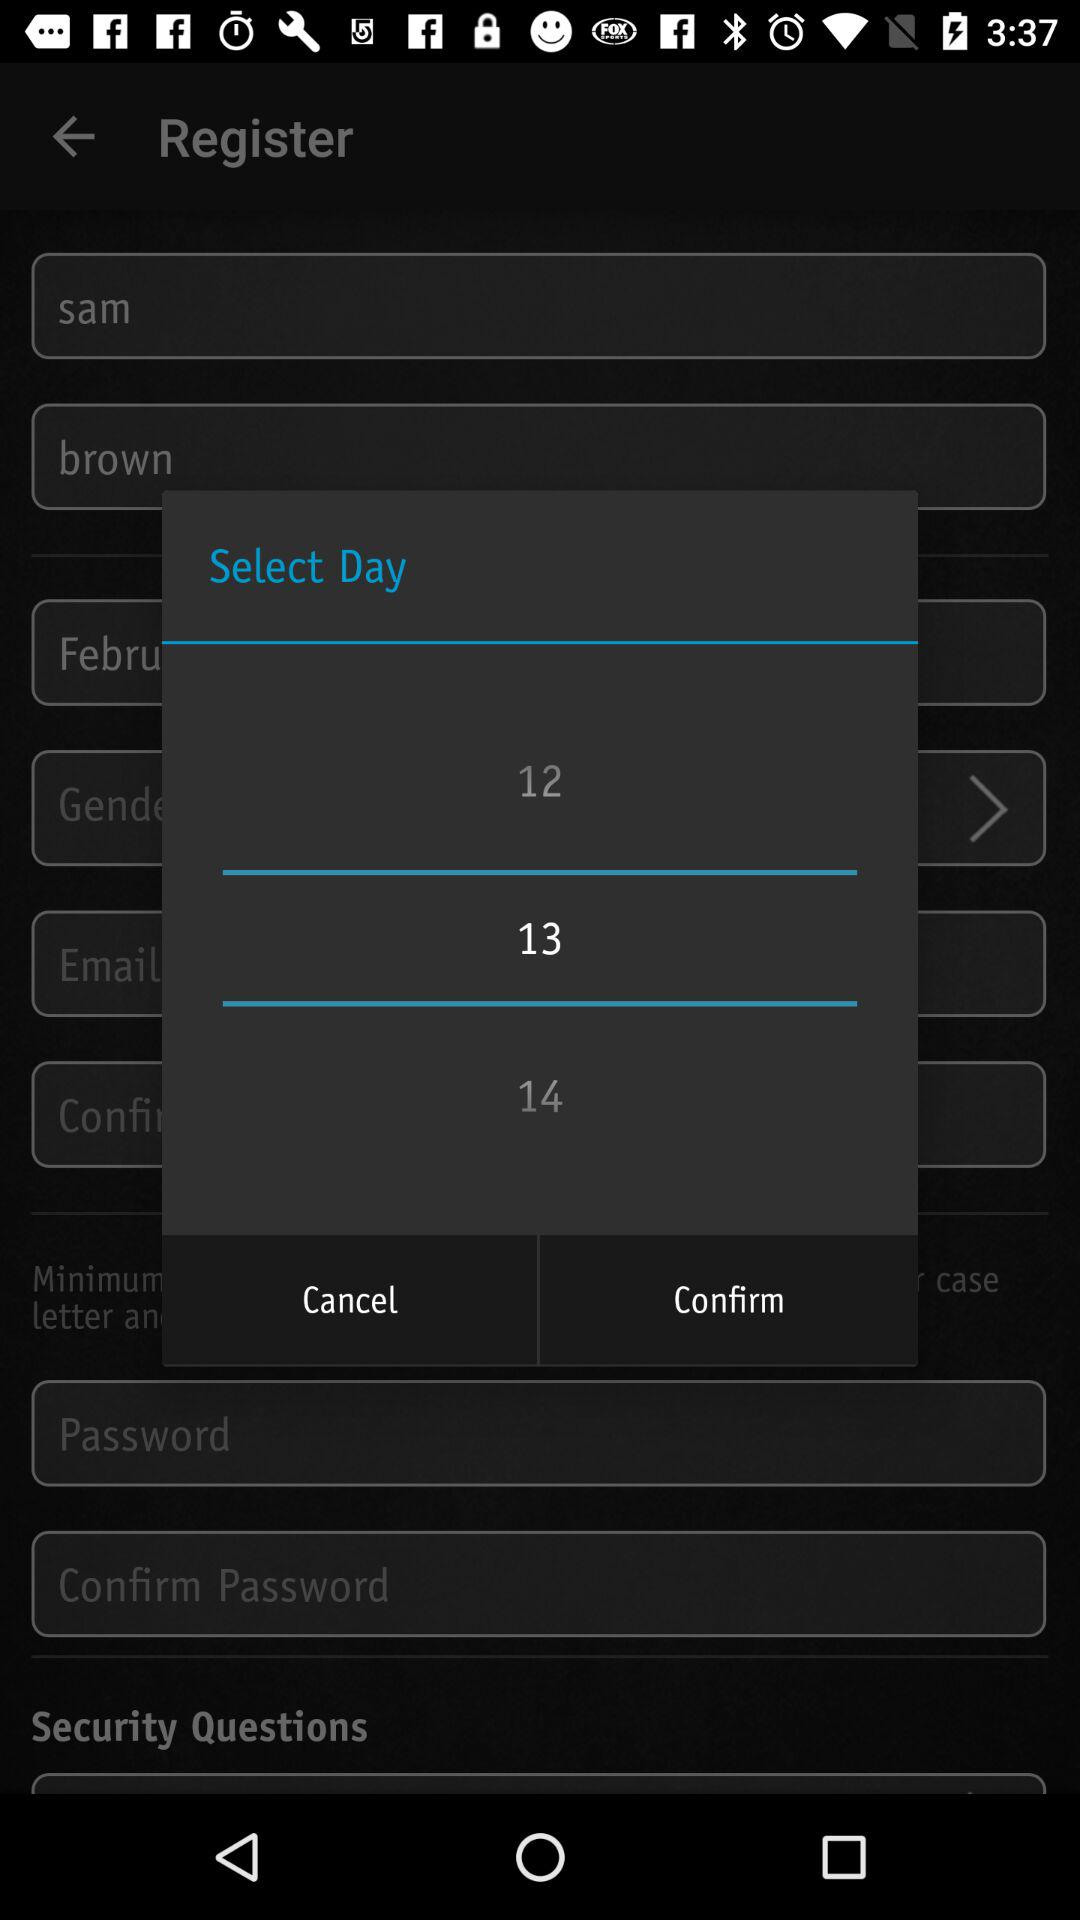How many days are displayed in the calendar?
Answer the question using a single word or phrase. 3 